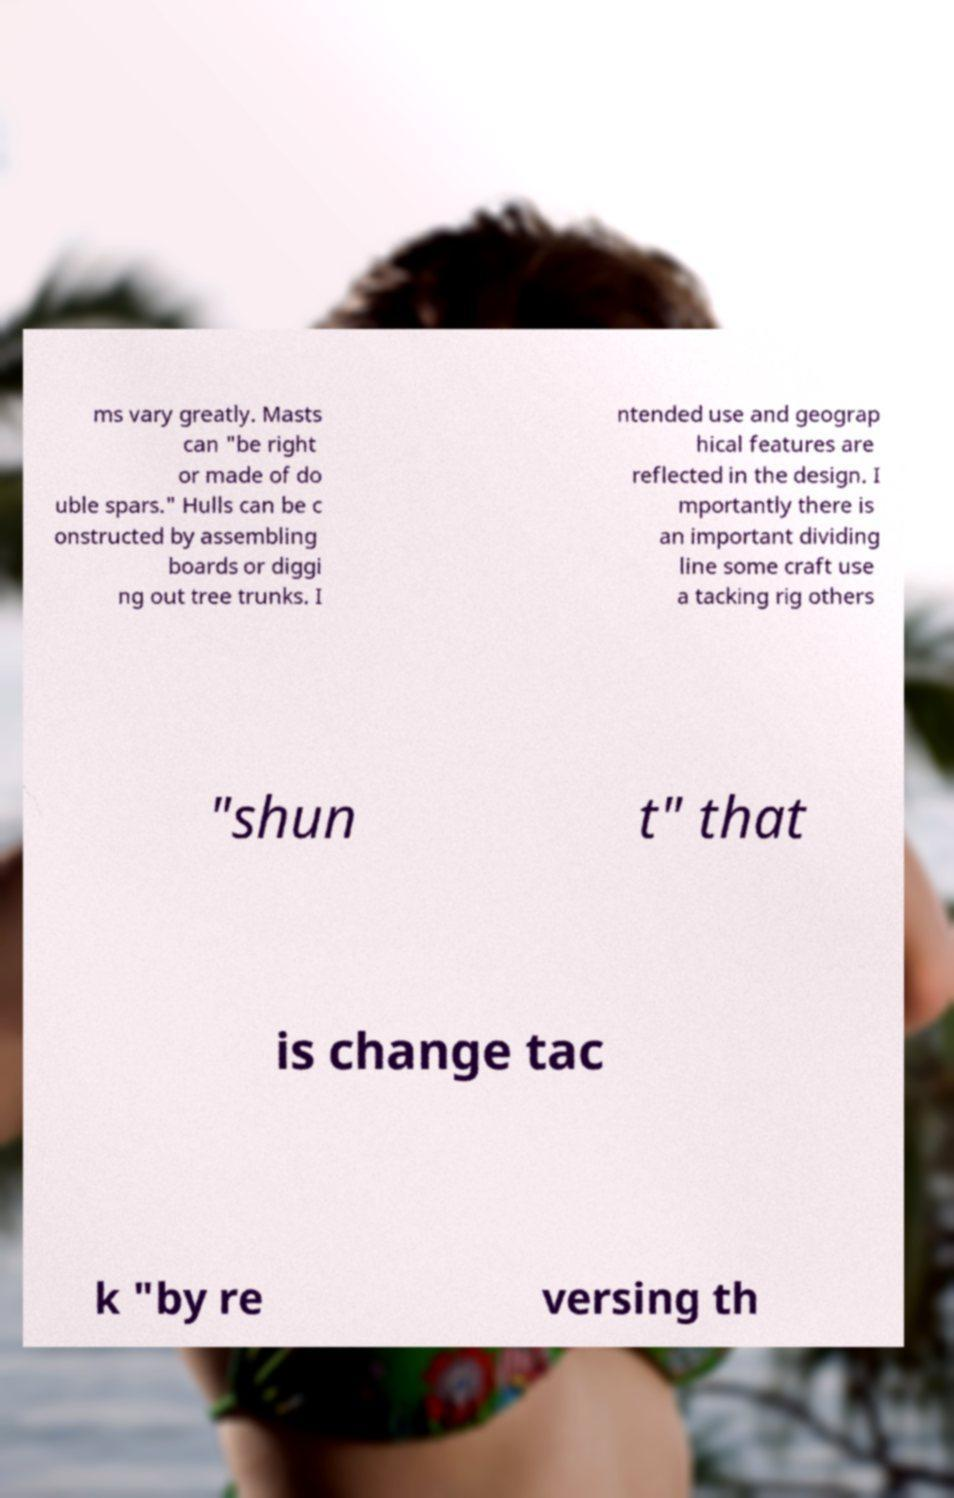Please read and relay the text visible in this image. What does it say? ms vary greatly. Masts can "be right or made of do uble spars." Hulls can be c onstructed by assembling boards or diggi ng out tree trunks. I ntended use and geograp hical features are reflected in the design. I mportantly there is an important dividing line some craft use a tacking rig others "shun t" that is change tac k "by re versing th 